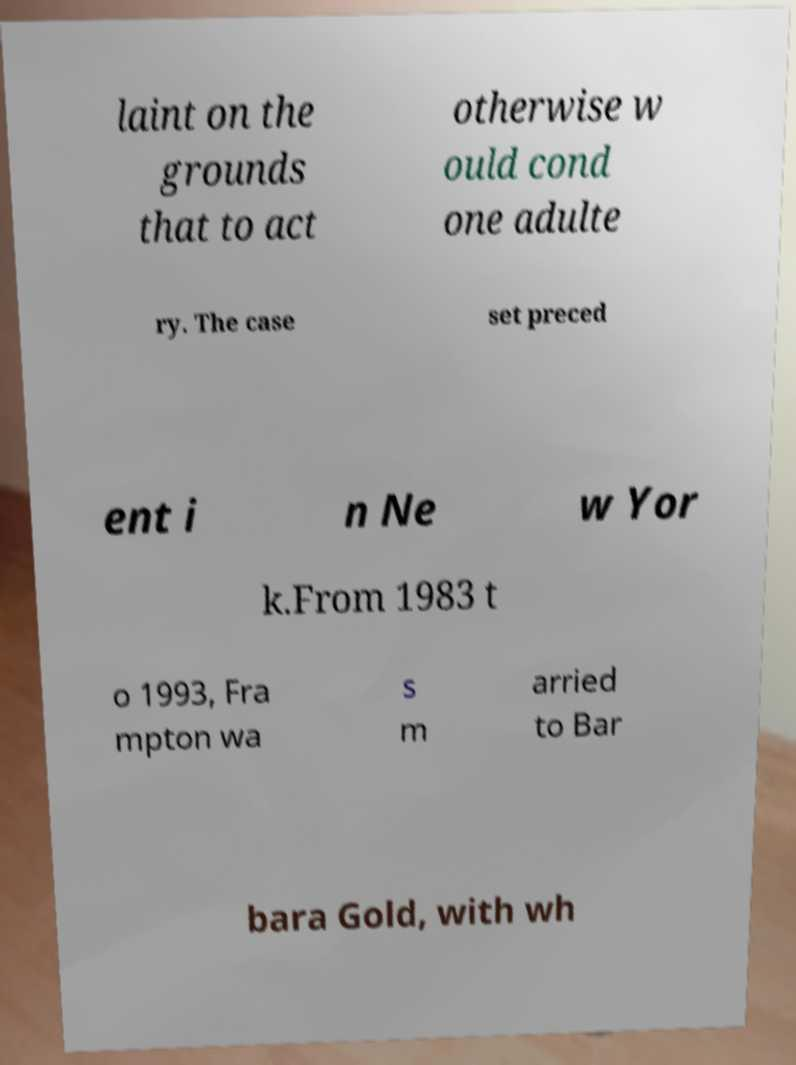Please read and relay the text visible in this image. What does it say? laint on the grounds that to act otherwise w ould cond one adulte ry. The case set preced ent i n Ne w Yor k.From 1983 t o 1993, Fra mpton wa s m arried to Bar bara Gold, with wh 